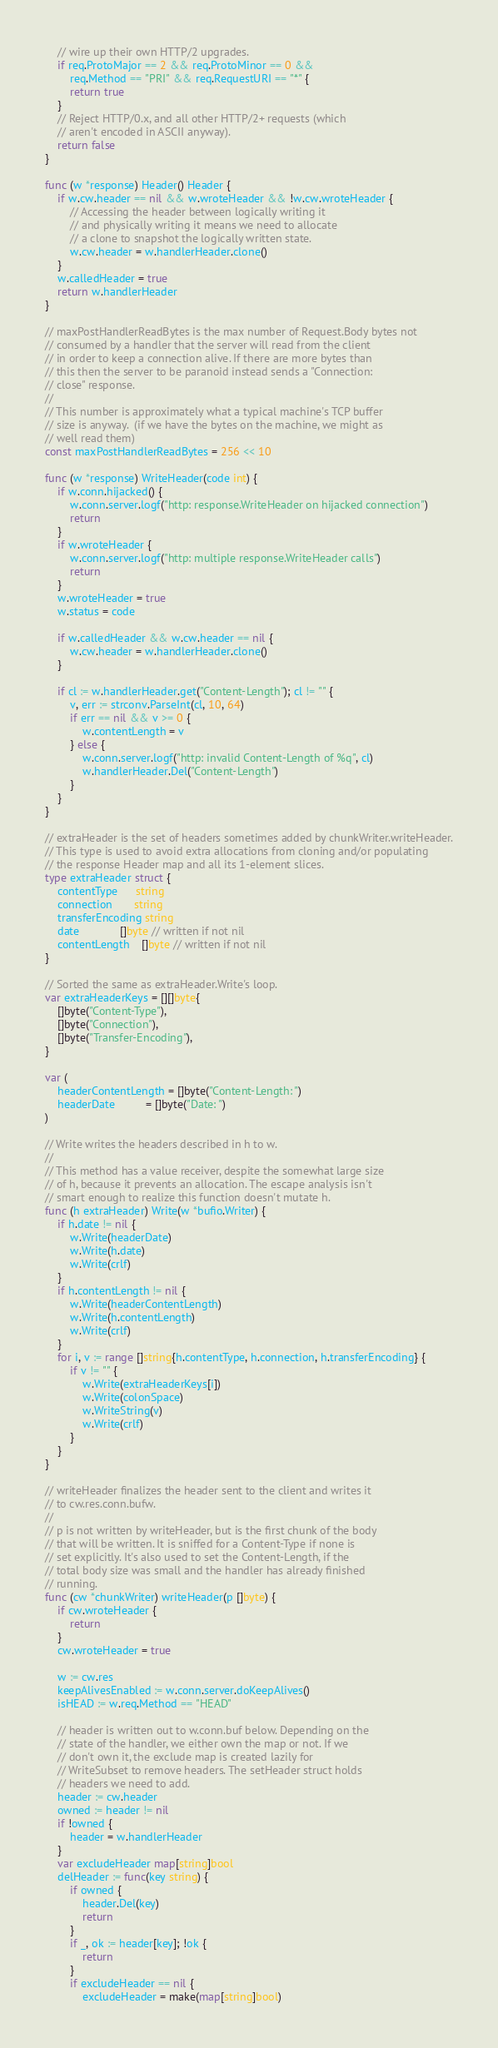<code> <loc_0><loc_0><loc_500><loc_500><_Go_>	// wire up their own HTTP/2 upgrades.
	if req.ProtoMajor == 2 && req.ProtoMinor == 0 &&
		req.Method == "PRI" && req.RequestURI == "*" {
		return true
	}
	// Reject HTTP/0.x, and all other HTTP/2+ requests (which
	// aren't encoded in ASCII anyway).
	return false
}

func (w *response) Header() Header {
	if w.cw.header == nil && w.wroteHeader && !w.cw.wroteHeader {
		// Accessing the header between logically writing it
		// and physically writing it means we need to allocate
		// a clone to snapshot the logically written state.
		w.cw.header = w.handlerHeader.clone()
	}
	w.calledHeader = true
	return w.handlerHeader
}

// maxPostHandlerReadBytes is the max number of Request.Body bytes not
// consumed by a handler that the server will read from the client
// in order to keep a connection alive. If there are more bytes than
// this then the server to be paranoid instead sends a "Connection:
// close" response.
//
// This number is approximately what a typical machine's TCP buffer
// size is anyway.  (if we have the bytes on the machine, we might as
// well read them)
const maxPostHandlerReadBytes = 256 << 10

func (w *response) WriteHeader(code int) {
	if w.conn.hijacked() {
		w.conn.server.logf("http: response.WriteHeader on hijacked connection")
		return
	}
	if w.wroteHeader {
		w.conn.server.logf("http: multiple response.WriteHeader calls")
		return
	}
	w.wroteHeader = true
	w.status = code

	if w.calledHeader && w.cw.header == nil {
		w.cw.header = w.handlerHeader.clone()
	}

	if cl := w.handlerHeader.get("Content-Length"); cl != "" {
		v, err := strconv.ParseInt(cl, 10, 64)
		if err == nil && v >= 0 {
			w.contentLength = v
		} else {
			w.conn.server.logf("http: invalid Content-Length of %q", cl)
			w.handlerHeader.Del("Content-Length")
		}
	}
}

// extraHeader is the set of headers sometimes added by chunkWriter.writeHeader.
// This type is used to avoid extra allocations from cloning and/or populating
// the response Header map and all its 1-element slices.
type extraHeader struct {
	contentType      string
	connection       string
	transferEncoding string
	date             []byte // written if not nil
	contentLength    []byte // written if not nil
}

// Sorted the same as extraHeader.Write's loop.
var extraHeaderKeys = [][]byte{
	[]byte("Content-Type"),
	[]byte("Connection"),
	[]byte("Transfer-Encoding"),
}

var (
	headerContentLength = []byte("Content-Length: ")
	headerDate          = []byte("Date: ")
)

// Write writes the headers described in h to w.
//
// This method has a value receiver, despite the somewhat large size
// of h, because it prevents an allocation. The escape analysis isn't
// smart enough to realize this function doesn't mutate h.
func (h extraHeader) Write(w *bufio.Writer) {
	if h.date != nil {
		w.Write(headerDate)
		w.Write(h.date)
		w.Write(crlf)
	}
	if h.contentLength != nil {
		w.Write(headerContentLength)
		w.Write(h.contentLength)
		w.Write(crlf)
	}
	for i, v := range []string{h.contentType, h.connection, h.transferEncoding} {
		if v != "" {
			w.Write(extraHeaderKeys[i])
			w.Write(colonSpace)
			w.WriteString(v)
			w.Write(crlf)
		}
	}
}

// writeHeader finalizes the header sent to the client and writes it
// to cw.res.conn.bufw.
//
// p is not written by writeHeader, but is the first chunk of the body
// that will be written. It is sniffed for a Content-Type if none is
// set explicitly. It's also used to set the Content-Length, if the
// total body size was small and the handler has already finished
// running.
func (cw *chunkWriter) writeHeader(p []byte) {
	if cw.wroteHeader {
		return
	}
	cw.wroteHeader = true

	w := cw.res
	keepAlivesEnabled := w.conn.server.doKeepAlives()
	isHEAD := w.req.Method == "HEAD"

	// header is written out to w.conn.buf below. Depending on the
	// state of the handler, we either own the map or not. If we
	// don't own it, the exclude map is created lazily for
	// WriteSubset to remove headers. The setHeader struct holds
	// headers we need to add.
	header := cw.header
	owned := header != nil
	if !owned {
		header = w.handlerHeader
	}
	var excludeHeader map[string]bool
	delHeader := func(key string) {
		if owned {
			header.Del(key)
			return
		}
		if _, ok := header[key]; !ok {
			return
		}
		if excludeHeader == nil {
			excludeHeader = make(map[string]bool)</code> 